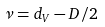Convert formula to latex. <formula><loc_0><loc_0><loc_500><loc_500>\nu = d _ { V } - D / 2</formula> 